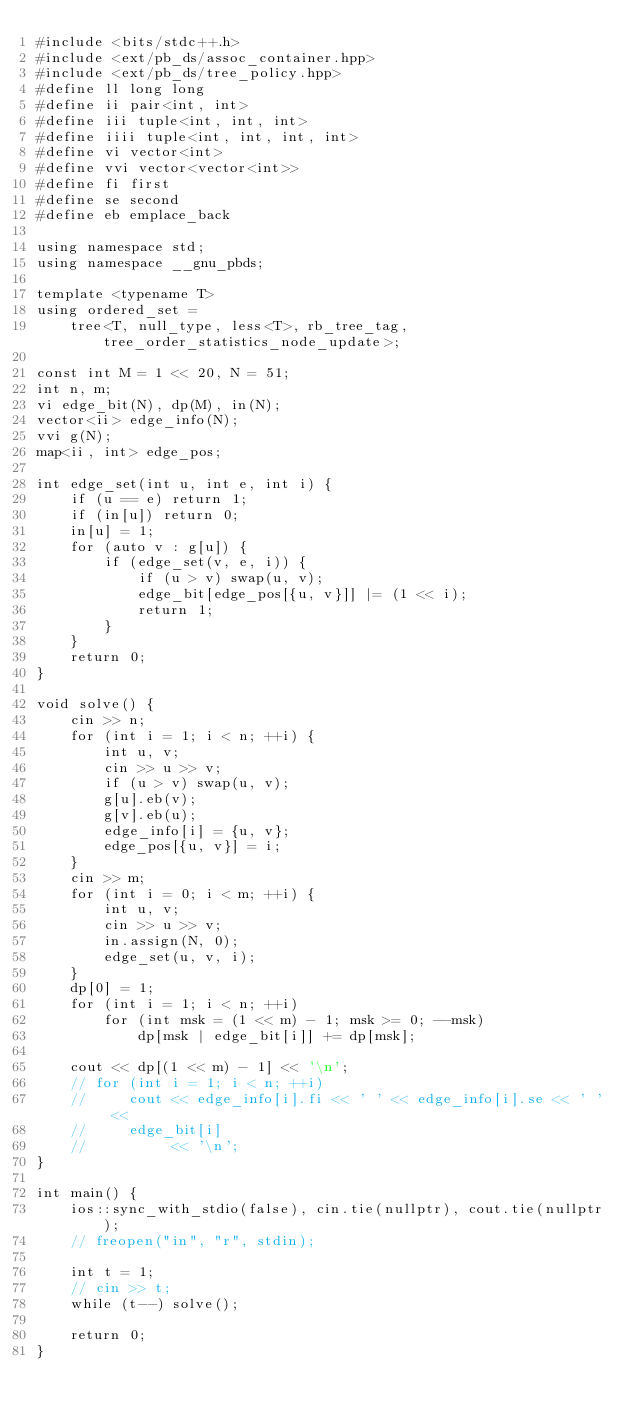Convert code to text. <code><loc_0><loc_0><loc_500><loc_500><_C++_>#include <bits/stdc++.h>
#include <ext/pb_ds/assoc_container.hpp>
#include <ext/pb_ds/tree_policy.hpp>
#define ll long long
#define ii pair<int, int>
#define iii tuple<int, int, int>
#define iiii tuple<int, int, int, int>
#define vi vector<int>
#define vvi vector<vector<int>>
#define fi first
#define se second
#define eb emplace_back

using namespace std;
using namespace __gnu_pbds;

template <typename T>
using ordered_set =
    tree<T, null_type, less<T>, rb_tree_tag, tree_order_statistics_node_update>;

const int M = 1 << 20, N = 51;
int n, m;
vi edge_bit(N), dp(M), in(N);
vector<ii> edge_info(N);
vvi g(N);
map<ii, int> edge_pos;

int edge_set(int u, int e, int i) {
    if (u == e) return 1;
    if (in[u]) return 0;
    in[u] = 1;
    for (auto v : g[u]) {
        if (edge_set(v, e, i)) {
            if (u > v) swap(u, v);
            edge_bit[edge_pos[{u, v}]] |= (1 << i);
            return 1;
        }
    }
    return 0;
}

void solve() {
    cin >> n;
    for (int i = 1; i < n; ++i) {
        int u, v;
        cin >> u >> v;
        if (u > v) swap(u, v);
        g[u].eb(v);
        g[v].eb(u);
        edge_info[i] = {u, v};
        edge_pos[{u, v}] = i;
    }
    cin >> m;
    for (int i = 0; i < m; ++i) {
        int u, v;
        cin >> u >> v;
        in.assign(N, 0);
        edge_set(u, v, i);
    }
    dp[0] = 1;
    for (int i = 1; i < n; ++i)
        for (int msk = (1 << m) - 1; msk >= 0; --msk)
            dp[msk | edge_bit[i]] += dp[msk];

    cout << dp[(1 << m) - 1] << '\n';
    // for (int i = 1; i < n; ++i)
    //     cout << edge_info[i].fi << ' ' << edge_info[i].se << ' ' <<
    //     edge_bit[i]
    //          << '\n';
}

int main() {
    ios::sync_with_stdio(false), cin.tie(nullptr), cout.tie(nullptr);
    // freopen("in", "r", stdin);

    int t = 1;
    // cin >> t;
    while (t--) solve();

    return 0;
}</code> 